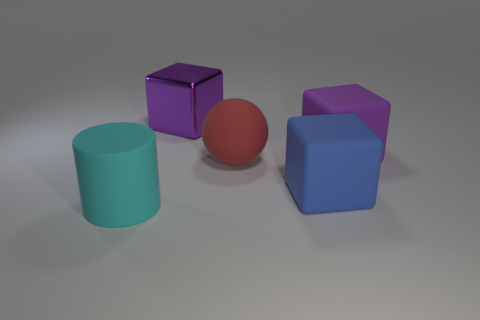Subtract all large purple blocks. How many blocks are left? 1 Add 3 big spheres. How many objects exist? 8 Subtract all green cylinders. How many purple blocks are left? 2 Subtract all blue cubes. How many cubes are left? 2 Subtract all balls. How many objects are left? 4 Add 4 purple matte blocks. How many purple matte blocks exist? 5 Subtract 0 brown blocks. How many objects are left? 5 Subtract 2 blocks. How many blocks are left? 1 Subtract all blue cylinders. Subtract all blue cubes. How many cylinders are left? 1 Subtract all yellow matte cubes. Subtract all blue objects. How many objects are left? 4 